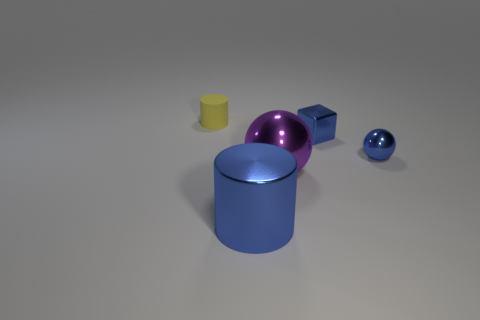How many large metallic spheres have the same color as the metallic block?
Provide a succinct answer. 0. What material is the ball that is the same size as the blue cylinder?
Your response must be concise. Metal. Are there any big balls that are in front of the cylinder on the right side of the yellow thing?
Keep it short and to the point. No. How many other things are the same color as the metallic cube?
Provide a succinct answer. 2. What size is the yellow cylinder?
Provide a succinct answer. Small. Is there a small gray rubber cube?
Your response must be concise. No. Is the number of blue metallic cylinders that are in front of the blue cylinder greater than the number of blue spheres that are behind the tiny cube?
Your answer should be very brief. No. There is a object that is left of the large sphere and in front of the small sphere; what is its material?
Provide a succinct answer. Metal. Is the small yellow object the same shape as the big blue shiny thing?
Provide a short and direct response. Yes. Is there any other thing that is the same size as the shiny block?
Your response must be concise. Yes. 